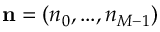Convert formula to latex. <formula><loc_0><loc_0><loc_500><loc_500>n = ( n _ { 0 } , \dots , n _ { M - 1 } )</formula> 